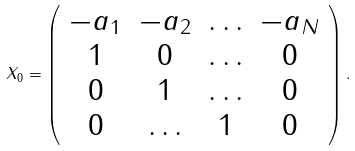<formula> <loc_0><loc_0><loc_500><loc_500>X _ { 0 } = \left ( \begin{array} { c c c c } { { - a _ { 1 } } } & { { - a _ { 2 } } } & { \dots } & { { - a _ { N } } } \\ { 1 } & { 0 } & { \dots } & { 0 } \\ { 0 } & { 1 } & { \dots } & { 0 } \\ { 0 } & { \dots } & { 1 } & { 0 } \end{array} \right ) .</formula> 